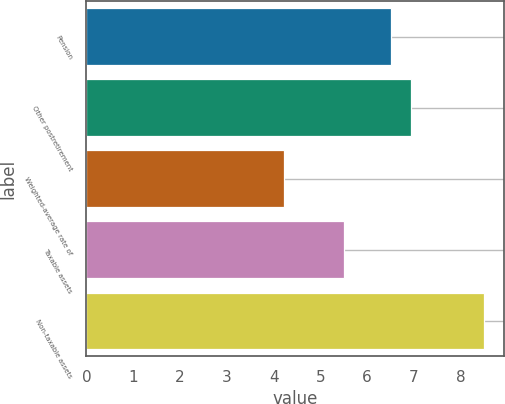<chart> <loc_0><loc_0><loc_500><loc_500><bar_chart><fcel>Pension<fcel>Other postretirement<fcel>Weighted-average rate of<fcel>Taxable assets<fcel>Non-taxable assets<nl><fcel>6.5<fcel>6.93<fcel>4.23<fcel>5.5<fcel>8.5<nl></chart> 